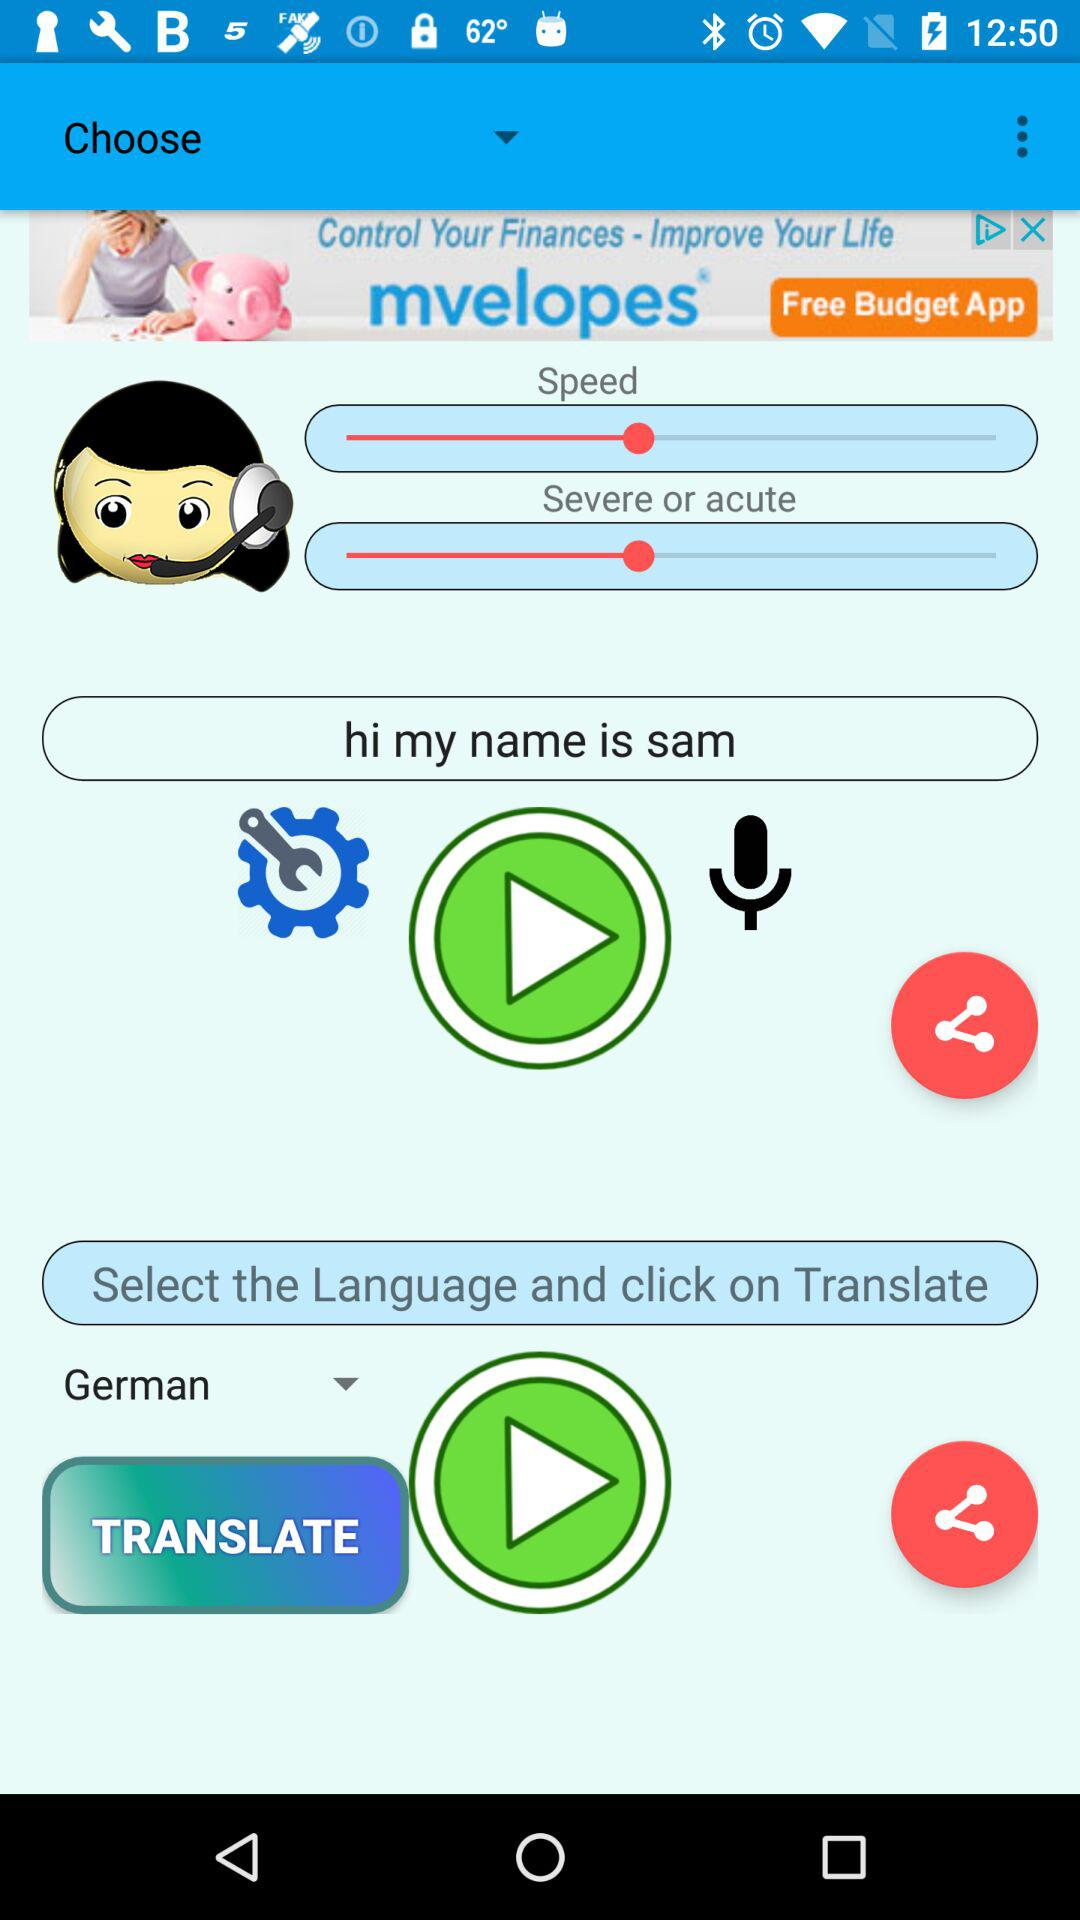Which language is selected? The selected language is German. 